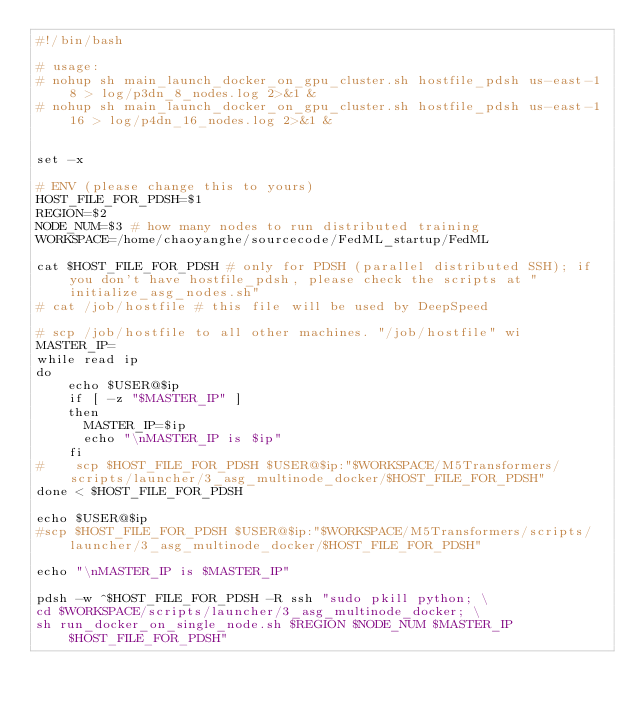Convert code to text. <code><loc_0><loc_0><loc_500><loc_500><_Bash_>#!/bin/bash

# usage:
# nohup sh main_launch_docker_on_gpu_cluster.sh hostfile_pdsh us-east-1 8 > log/p3dn_8_nodes.log 2>&1 &
# nohup sh main_launch_docker_on_gpu_cluster.sh hostfile_pdsh us-east-1 16 > log/p4dn_16_nodes.log 2>&1 &


set -x

# ENV (please change this to yours)
HOST_FILE_FOR_PDSH=$1
REGION=$2
NODE_NUM=$3 # how many nodes to run distributed training
WORKSPACE=/home/chaoyanghe/sourcecode/FedML_startup/FedML

cat $HOST_FILE_FOR_PDSH # only for PDSH (parallel distributed SSH); if you don't have hostfile_pdsh, please check the scripts at "initialize_asg_nodes.sh"
# cat /job/hostfile # this file will be used by DeepSpeed

# scp /job/hostfile to all other machines. "/job/hostfile" wi
MASTER_IP=
while read ip
do
    echo $USER@$ip
    if [ -z "$MASTER_IP" ]
    then
      MASTER_IP=$ip
      echo "\nMASTER_IP is $ip"
    fi
#    scp $HOST_FILE_FOR_PDSH $USER@$ip:"$WORKSPACE/M5Transformers/scripts/launcher/3_asg_multinode_docker/$HOST_FILE_FOR_PDSH"
done < $HOST_FILE_FOR_PDSH

echo $USER@$ip
#scp $HOST_FILE_FOR_PDSH $USER@$ip:"$WORKSPACE/M5Transformers/scripts/launcher/3_asg_multinode_docker/$HOST_FILE_FOR_PDSH"

echo "\nMASTER_IP is $MASTER_IP"

pdsh -w ^$HOST_FILE_FOR_PDSH -R ssh "sudo pkill python; \
cd $WORKSPACE/scripts/launcher/3_asg_multinode_docker; \
sh run_docker_on_single_node.sh $REGION $NODE_NUM $MASTER_IP $HOST_FILE_FOR_PDSH"</code> 